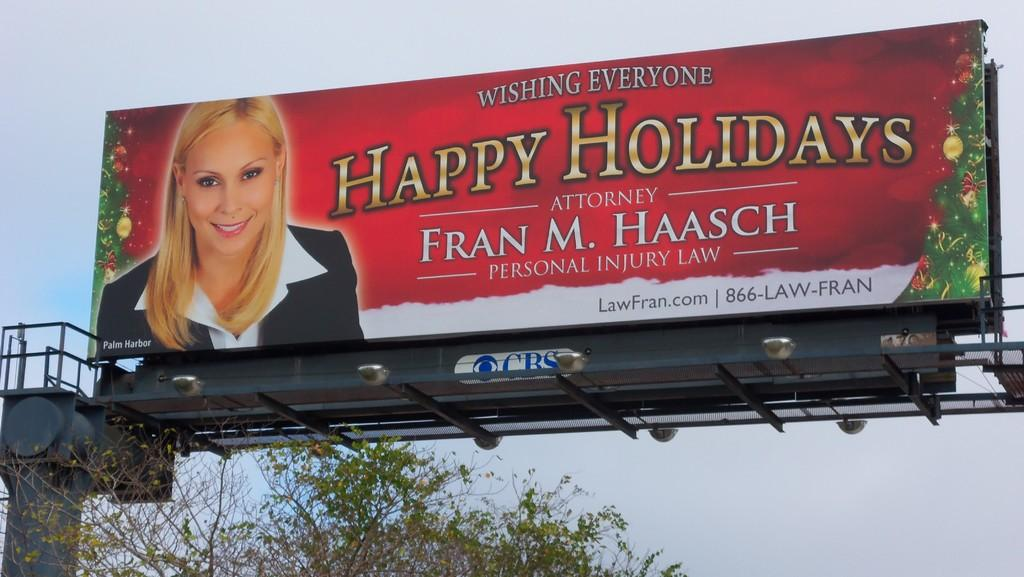Provide a one-sentence caption for the provided image. A billboard for Attorney Fran M. Haasch wishing everyone happy holidays. 